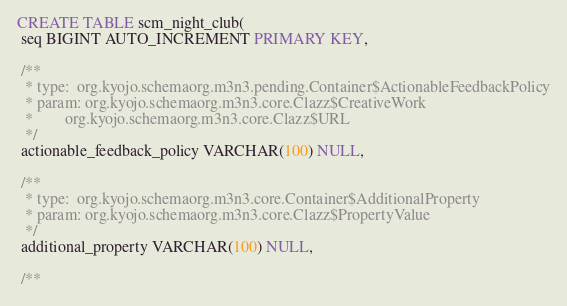<code> <loc_0><loc_0><loc_500><loc_500><_SQL_>CREATE TABLE scm_night_club(
 seq BIGINT AUTO_INCREMENT PRIMARY KEY,

 /**
  * type:  org.kyojo.schemaorg.m3n3.pending.Container$ActionableFeedbackPolicy
  * param: org.kyojo.schemaorg.m3n3.core.Clazz$CreativeWork
  *        org.kyojo.schemaorg.m3n3.core.Clazz$URL
  */
 actionable_feedback_policy VARCHAR(100) NULL,

 /**
  * type:  org.kyojo.schemaorg.m3n3.core.Container$AdditionalProperty
  * param: org.kyojo.schemaorg.m3n3.core.Clazz$PropertyValue
  */
 additional_property VARCHAR(100) NULL,

 /**</code> 